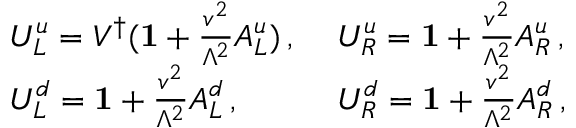Convert formula to latex. <formula><loc_0><loc_0><loc_500><loc_500>\begin{array} { l l } { { U _ { L } ^ { u } = V ^ { \dagger } ( { 1 } + \frac { v ^ { 2 } } { \Lambda ^ { 2 } } A _ { L } ^ { u } ) \, , } } & { { U _ { R } ^ { u } = { 1 } + \frac { v ^ { 2 } } { \Lambda ^ { 2 } } A _ { R } ^ { u } \, , } } \\ { { U _ { L } ^ { d } = { 1 } + \frac { v ^ { 2 } } { \Lambda ^ { 2 } } A _ { L } ^ { d } \, , } } & { { U _ { R } ^ { d } = { 1 } + \frac { v ^ { 2 } } { \Lambda ^ { 2 } } A _ { R } ^ { d } \, , } } \end{array}</formula> 